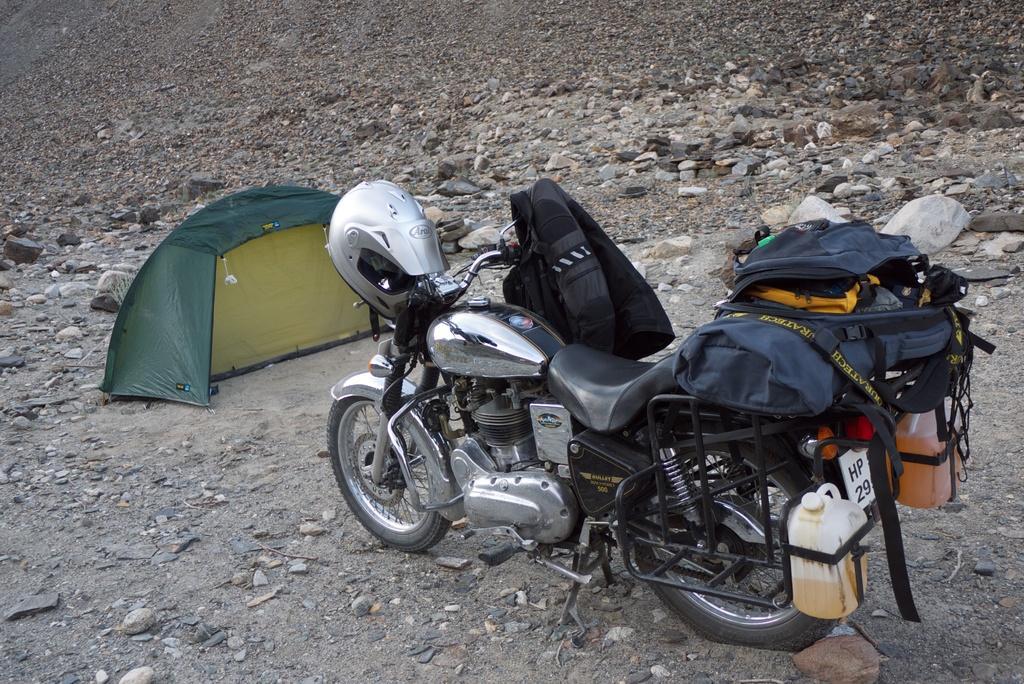Could you give a brief overview of what you see in this image? It is a bike, there are bags on it and a helmet. On the left side there is a tent in this image. 